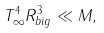<formula> <loc_0><loc_0><loc_500><loc_500>T _ { \infty } ^ { 4 } R _ { b i g } ^ { 3 } \ll M ,</formula> 